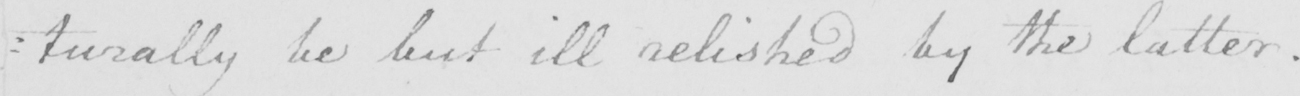Transcribe the text shown in this historical manuscript line. : turally be but ill relished by the latter . 